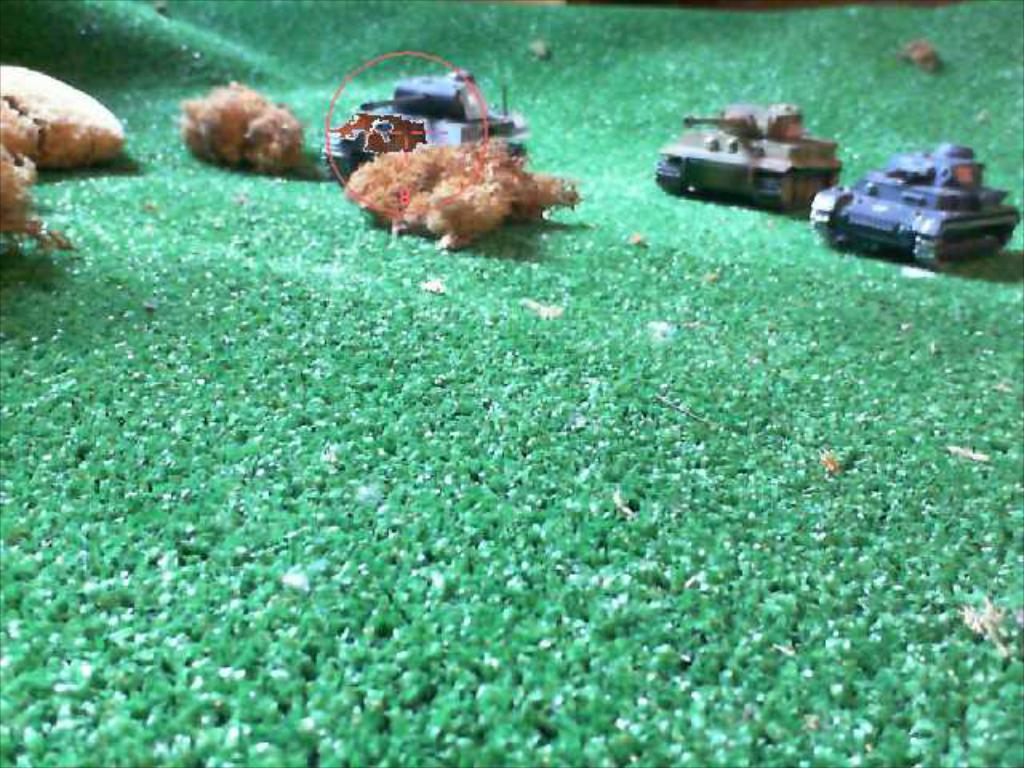What type of objects can be seen in the image? There are three toy vehicles in the image. What color are some of the objects in the image? There are brown color objects in the image. What color is the floor in the image? The floor in the image is green. Where is the park located in the image? There is no park present in the image. What type of tin can be seen in the image? There is no tin present in the image. 